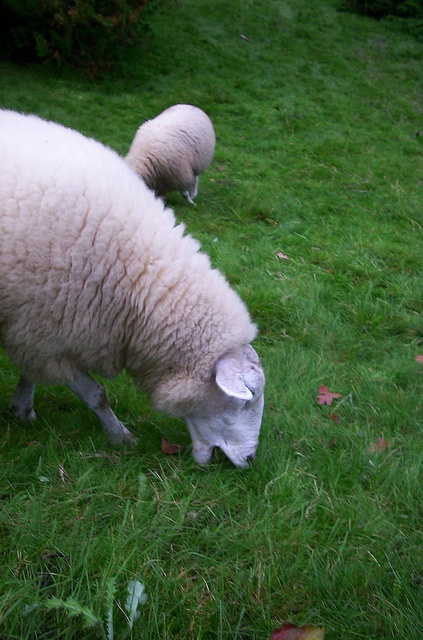Describe the objects in this image and their specific colors. I can see sheep in black, lavender, gray, and darkgray tones and sheep in black, lavender, darkgray, and gray tones in this image. 